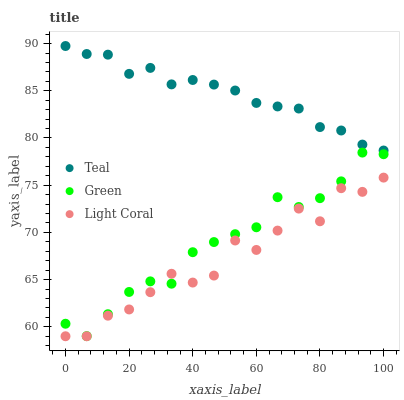Does Light Coral have the minimum area under the curve?
Answer yes or no. Yes. Does Teal have the maximum area under the curve?
Answer yes or no. Yes. Does Green have the minimum area under the curve?
Answer yes or no. No. Does Green have the maximum area under the curve?
Answer yes or no. No. Is Teal the smoothest?
Answer yes or no. Yes. Is Light Coral the roughest?
Answer yes or no. Yes. Is Green the smoothest?
Answer yes or no. No. Is Green the roughest?
Answer yes or no. No. Does Light Coral have the lowest value?
Answer yes or no. Yes. Does Green have the lowest value?
Answer yes or no. No. Does Teal have the highest value?
Answer yes or no. Yes. Does Green have the highest value?
Answer yes or no. No. Is Light Coral less than Teal?
Answer yes or no. Yes. Is Teal greater than Green?
Answer yes or no. Yes. Does Light Coral intersect Green?
Answer yes or no. Yes. Is Light Coral less than Green?
Answer yes or no. No. Is Light Coral greater than Green?
Answer yes or no. No. Does Light Coral intersect Teal?
Answer yes or no. No. 